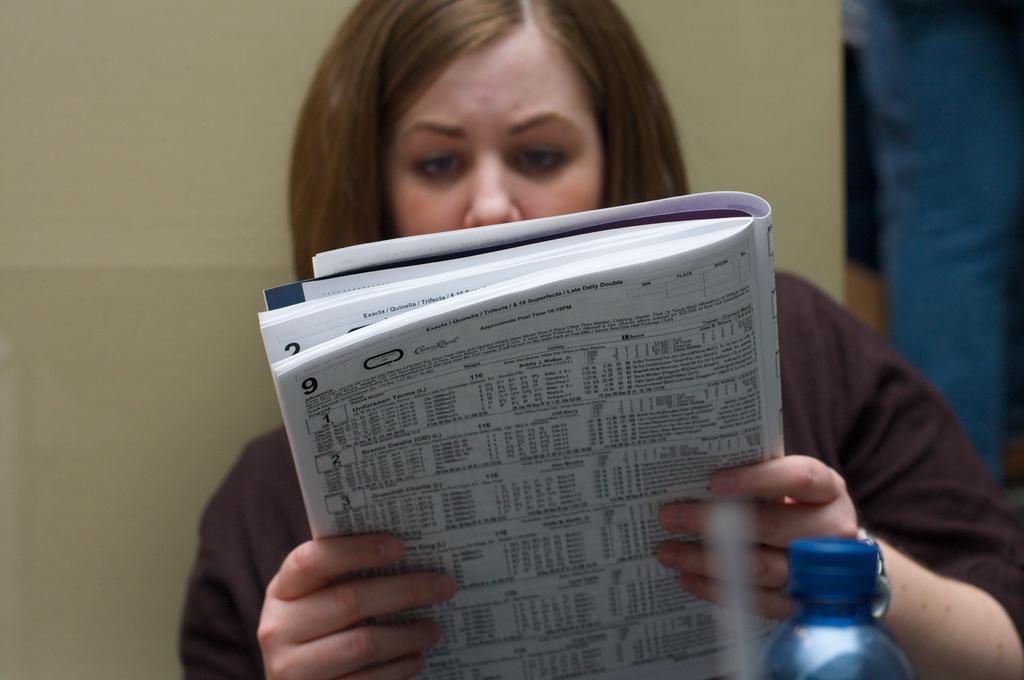How would you summarize this image in a sentence or two? In this image there is a lady. She is holding a book. There is a bottle in front of her. Behind her there is a yellow wall. 